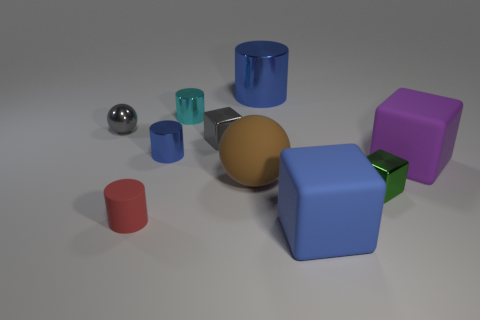Subtract all green cylinders. Subtract all cyan balls. How many cylinders are left? 4 Subtract all spheres. How many objects are left? 8 Add 7 green metal cubes. How many green metal cubes are left? 8 Add 4 cyan metallic cylinders. How many cyan metallic cylinders exist? 5 Subtract 0 brown blocks. How many objects are left? 10 Subtract all big yellow objects. Subtract all small gray things. How many objects are left? 8 